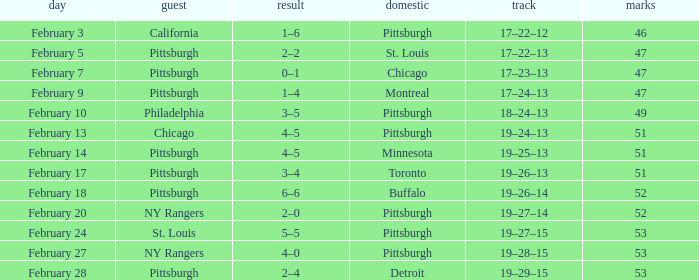Can you give me this table as a dict? {'header': ['day', 'guest', 'result', 'domestic', 'track', 'marks'], 'rows': [['February 3', 'California', '1–6', 'Pittsburgh', '17–22–12', '46'], ['February 5', 'Pittsburgh', '2–2', 'St. Louis', '17–22–13', '47'], ['February 7', 'Pittsburgh', '0–1', 'Chicago', '17–23–13', '47'], ['February 9', 'Pittsburgh', '1–4', 'Montreal', '17–24–13', '47'], ['February 10', 'Philadelphia', '3–5', 'Pittsburgh', '18–24–13', '49'], ['February 13', 'Chicago', '4–5', 'Pittsburgh', '19–24–13', '51'], ['February 14', 'Pittsburgh', '4–5', 'Minnesota', '19–25–13', '51'], ['February 17', 'Pittsburgh', '3–4', 'Toronto', '19–26–13', '51'], ['February 18', 'Pittsburgh', '6–6', 'Buffalo', '19–26–14', '52'], ['February 20', 'NY Rangers', '2–0', 'Pittsburgh', '19–27–14', '52'], ['February 24', 'St. Louis', '5–5', 'Pittsburgh', '19–27–15', '53'], ['February 27', 'NY Rangers', '4–0', 'Pittsburgh', '19–28–15', '53'], ['February 28', 'Pittsburgh', '2–4', 'Detroit', '19–29–15', '53']]} Which Score has a Date of february 9? 1–4. 